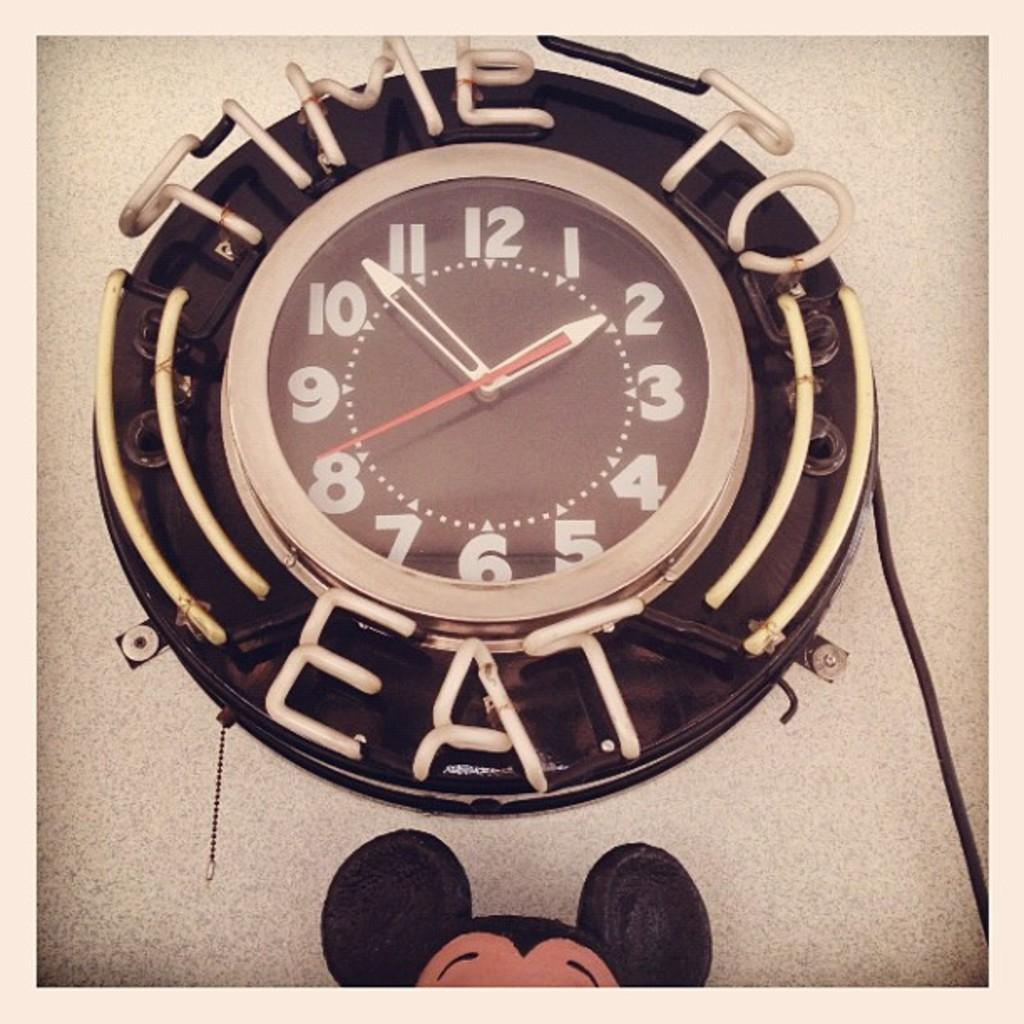Provide a one-sentence caption for the provided image. A clock says it's time to eat with a time of 1:54. 